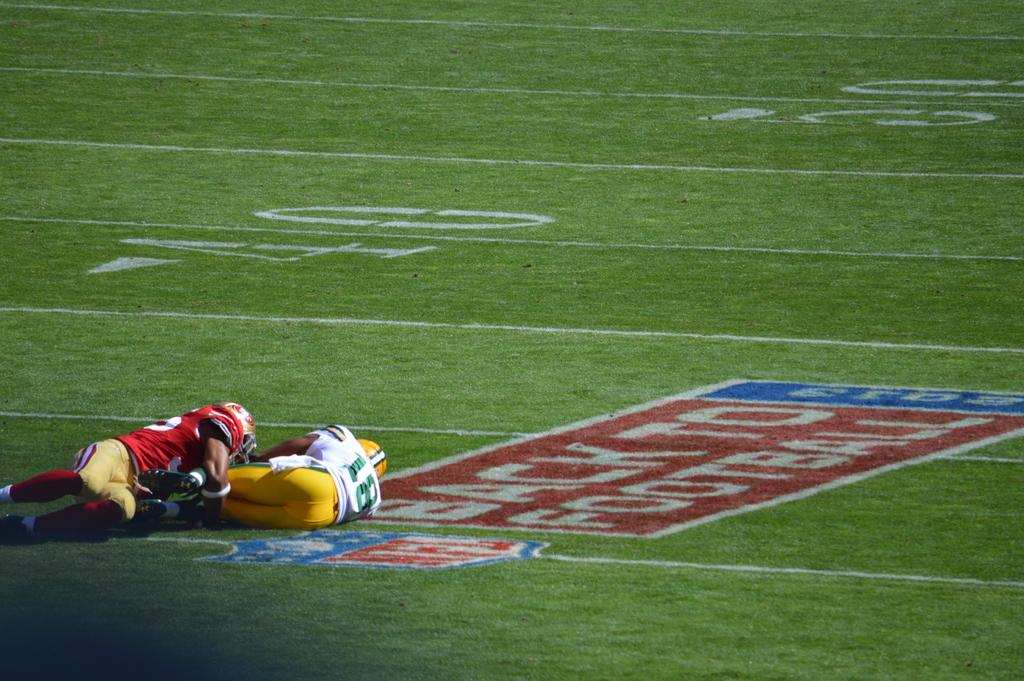What are the people in the image doing? The persons in the image are laying on the ground in the center of the image. What type of surface are they laying on? There is grass on the ground where they are laying. Is there any text visible in the image? Yes, there is some text written on the ground in the center of the image. What time period does the pail in the image belong to? There is no pail present in the image. What historical event is depicted in the image? The image does not depict any historical event; it shows persons laying on the ground with text written on the grass. 